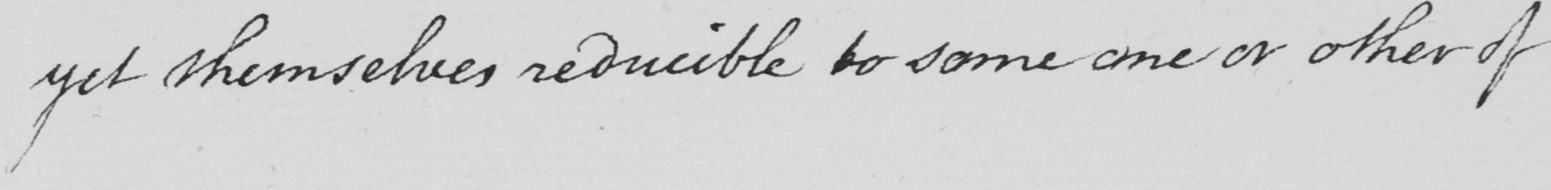Can you tell me what this handwritten text says? yet themselves reducible to some one or other of 